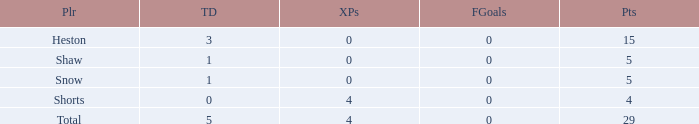Parse the full table. {'header': ['Plr', 'TD', 'XPs', 'FGoals', 'Pts'], 'rows': [['Heston', '3', '0', '0', '15'], ['Shaw', '1', '0', '0', '5'], ['Snow', '1', '0', '0', '5'], ['Shorts', '0', '4', '0', '4'], ['Total', '5', '4', '0', '29']]} What is the total number of field goals for a player that had less than 3 touchdowns, had 4 points, and had less than 4 extra points? 0.0. 